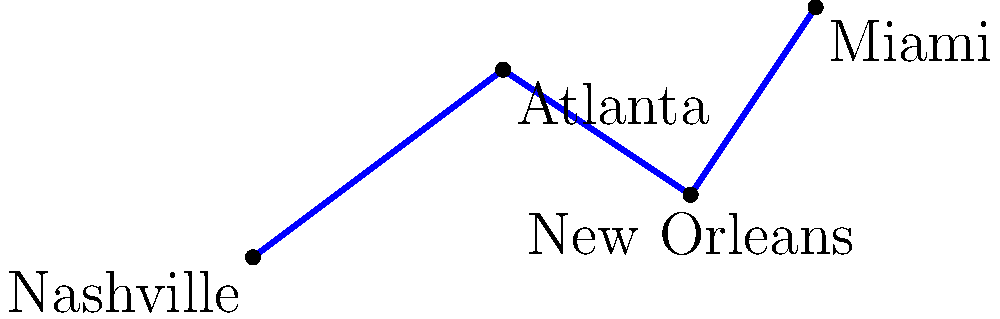Lucinda Williams is planning her next tour across the Southern United States. The map shows her proposed route connecting Nashville, Atlanta, New Orleans, and Miami. If each unit on the map represents 100 miles, estimate the total distance of her tour route to the nearest 100 miles. To estimate the total distance of Lucinda Williams' tour route, we need to calculate the length of each line segment and sum them up. We'll use the distance formula for each segment:

1. Nashville to Atlanta:
   $d = \sqrt{(x_2-x_1)^2 + (y_2-y_1)^2} = \sqrt{(4-0)^2 + (3-0)^2} = \sqrt{16 + 9} = \sqrt{25} = 5$ units

2. Atlanta to New Orleans:
   $d = \sqrt{(7-4)^2 + (1-3)^2} = \sqrt{9 + 4} = \sqrt{13} \approx 3.61$ units

3. New Orleans to Miami:
   $d = \sqrt{(9-7)^2 + (4-1)^2} = \sqrt{4 + 9} = \sqrt{13} \approx 3.61$ units

Total distance in units: $5 + 3.61 + 3.61 = 12.22$ units

Since each unit represents 100 miles:
Total distance in miles = $12.22 \times 100 = 1,222$ miles

Rounding to the nearest 100 miles: 1,200 miles
Answer: 1,200 miles 